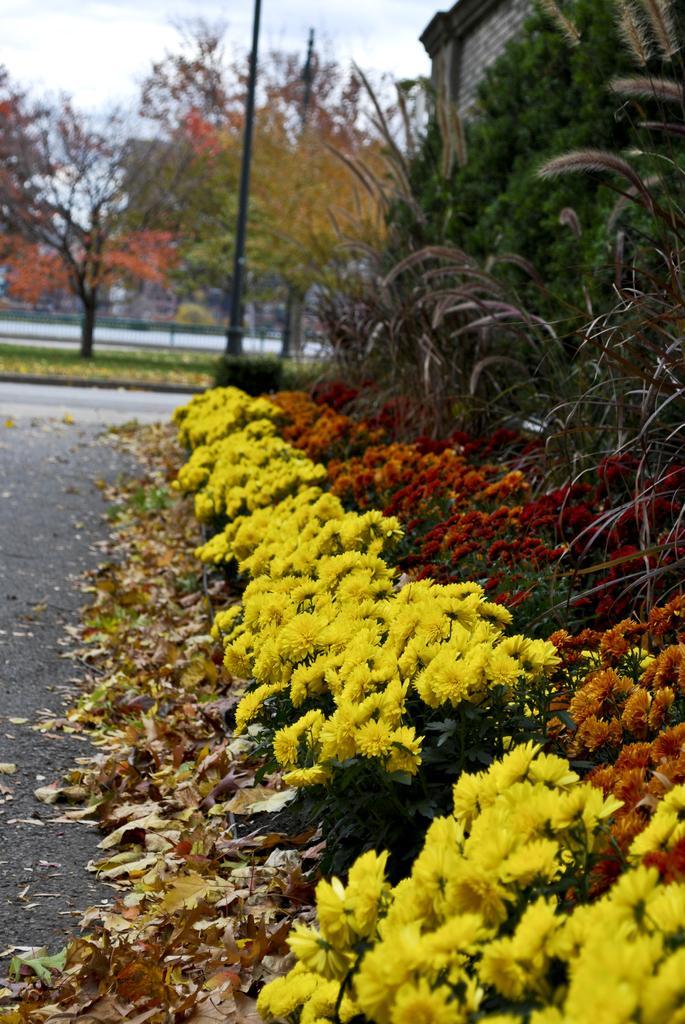Please provide a concise description of this image. In this image we can see some plants with flowers on it, there are some trees, leaves, pole, road and the wall, in the background we can see the sky. 